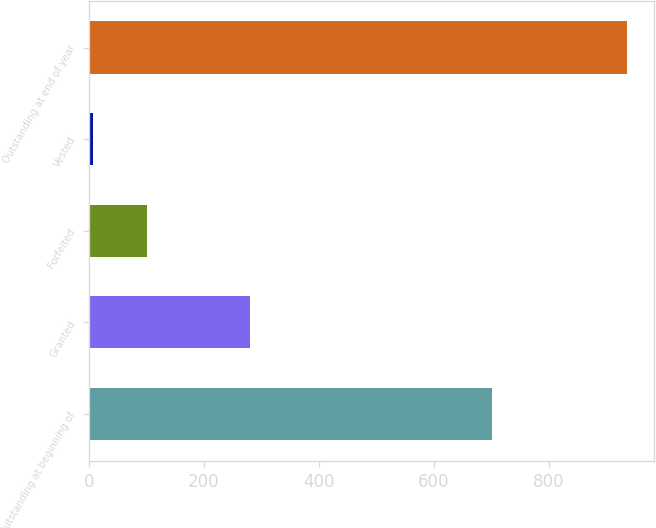<chart> <loc_0><loc_0><loc_500><loc_500><bar_chart><fcel>Outstanding at beginning of<fcel>Granted<fcel>Forfeited<fcel>Vested<fcel>Outstanding at end of year<nl><fcel>702<fcel>281<fcel>100<fcel>7<fcel>937<nl></chart> 